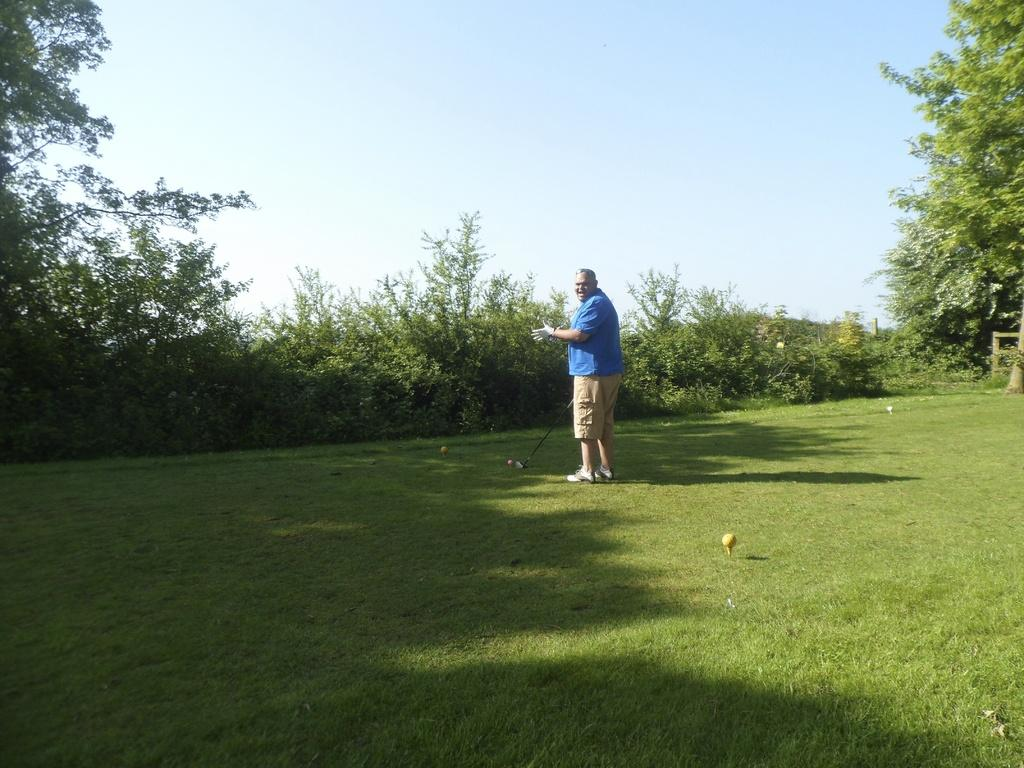Who is present in the image? There is a man in the image. What is the man doing in the image? The man is playing a golf game in the image. What is the man standing on? The man is standing on the ground in the image. What can be seen in the background around the man? There are trees and plants around the man in the image. What shape is the crib in the image? There is no crib present in the image. What type of club is the man holding in the image? The provided facts do not mention the type of club the man is holding; it only states that he is playing a golf game. 